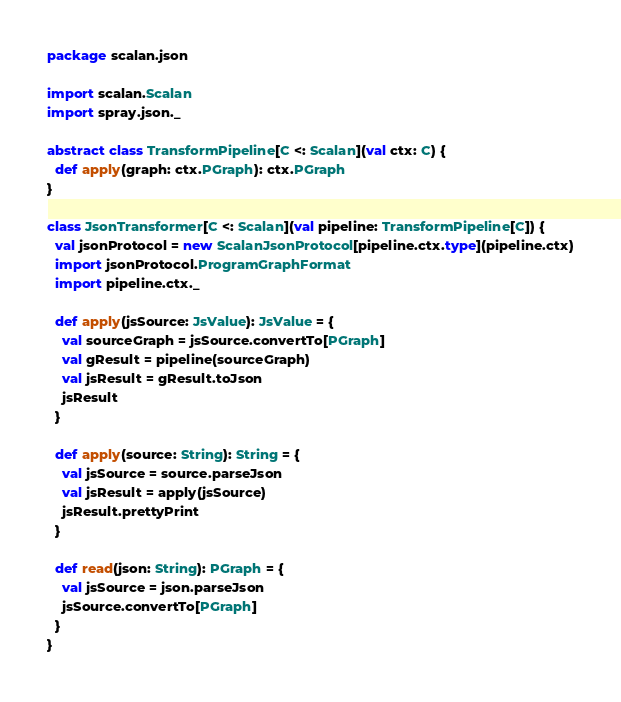Convert code to text. <code><loc_0><loc_0><loc_500><loc_500><_Scala_>package scalan.json

import scalan.Scalan
import spray.json._

abstract class TransformPipeline[C <: Scalan](val ctx: C) {
  def apply(graph: ctx.PGraph): ctx.PGraph
}

class JsonTransformer[C <: Scalan](val pipeline: TransformPipeline[C]) {
  val jsonProtocol = new ScalanJsonProtocol[pipeline.ctx.type](pipeline.ctx)
  import jsonProtocol.ProgramGraphFormat
  import pipeline.ctx._

  def apply(jsSource: JsValue): JsValue = {
    val sourceGraph = jsSource.convertTo[PGraph]
    val gResult = pipeline(sourceGraph)
    val jsResult = gResult.toJson
    jsResult
  }

  def apply(source: String): String = {
    val jsSource = source.parseJson
    val jsResult = apply(jsSource)
    jsResult.prettyPrint
  }

  def read(json: String): PGraph = {
    val jsSource = json.parseJson
    jsSource.convertTo[PGraph]
  }
}
</code> 